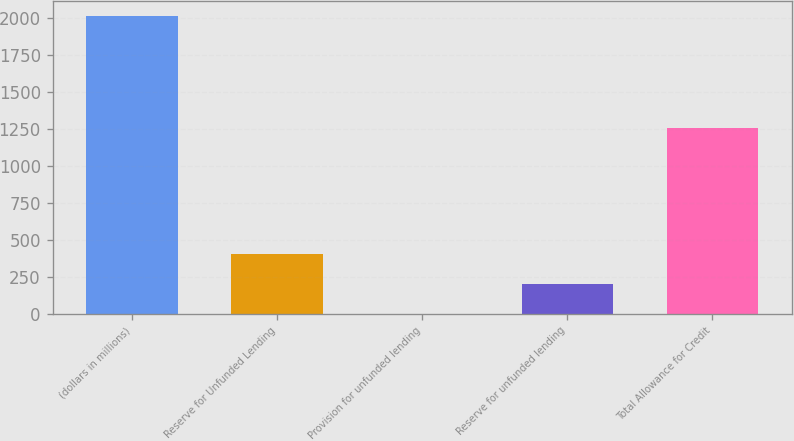Convert chart to OTSL. <chart><loc_0><loc_0><loc_500><loc_500><bar_chart><fcel>(dollars in millions)<fcel>Reserve for Unfunded Lending<fcel>Provision for unfunded lending<fcel>Reserve for unfunded lending<fcel>Total Allowance for Credit<nl><fcel>2013<fcel>403.4<fcel>1<fcel>202.2<fcel>1260<nl></chart> 